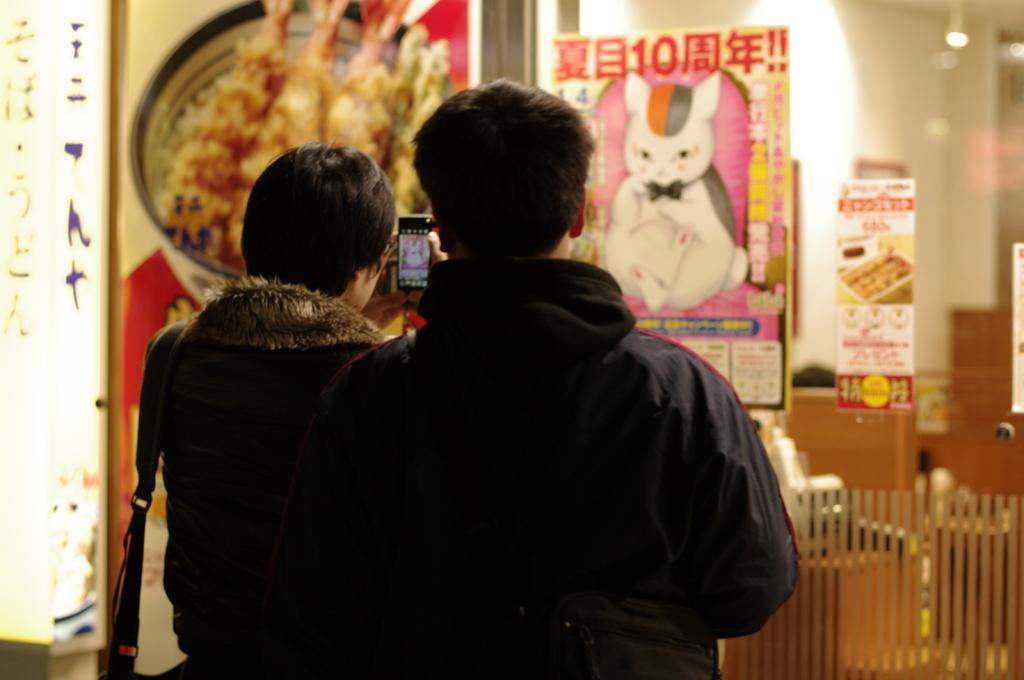How would you summarize this image in a sentence or two? In the image I can see two people, among them a person is holding the phone and to the side there are some posters to the walls. 